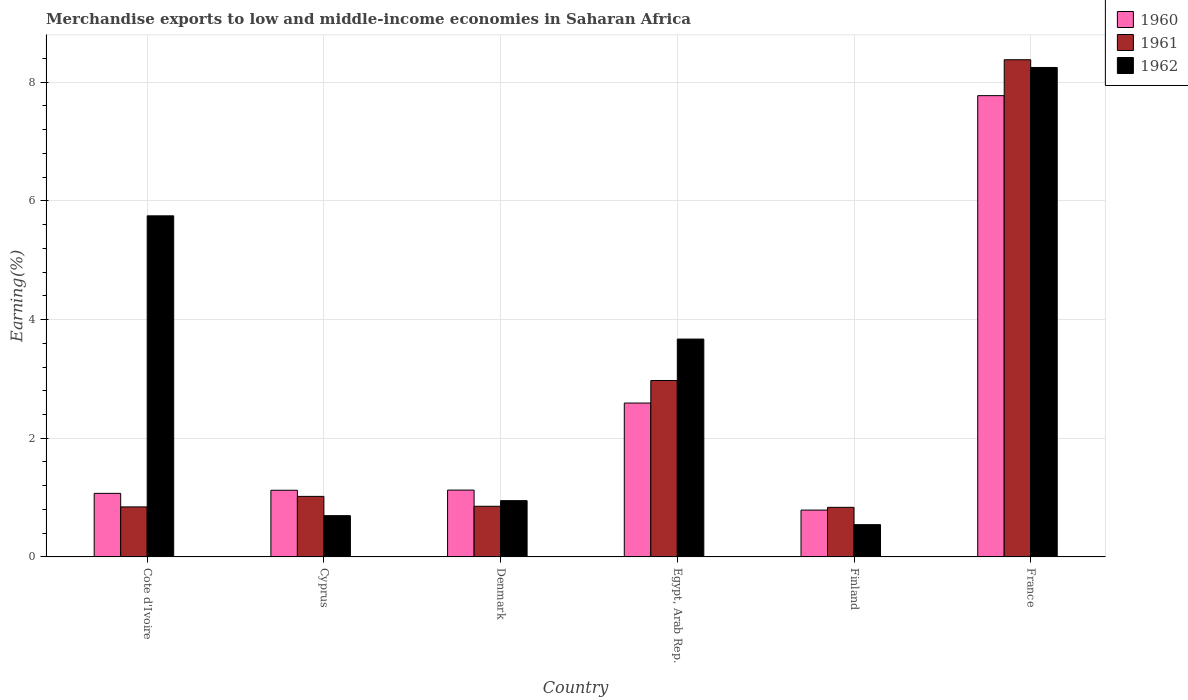How many different coloured bars are there?
Your answer should be compact. 3. Are the number of bars on each tick of the X-axis equal?
Your answer should be compact. Yes. How many bars are there on the 6th tick from the left?
Provide a succinct answer. 3. What is the label of the 1st group of bars from the left?
Ensure brevity in your answer.  Cote d'Ivoire. In how many cases, is the number of bars for a given country not equal to the number of legend labels?
Your answer should be compact. 0. What is the percentage of amount earned from merchandise exports in 1962 in Egypt, Arab Rep.?
Make the answer very short. 3.67. Across all countries, what is the maximum percentage of amount earned from merchandise exports in 1960?
Your response must be concise. 7.77. Across all countries, what is the minimum percentage of amount earned from merchandise exports in 1960?
Ensure brevity in your answer.  0.79. What is the total percentage of amount earned from merchandise exports in 1961 in the graph?
Your answer should be compact. 14.91. What is the difference between the percentage of amount earned from merchandise exports in 1962 in Cote d'Ivoire and that in Cyprus?
Make the answer very short. 5.05. What is the difference between the percentage of amount earned from merchandise exports in 1960 in Finland and the percentage of amount earned from merchandise exports in 1962 in Cote d'Ivoire?
Make the answer very short. -4.96. What is the average percentage of amount earned from merchandise exports in 1960 per country?
Provide a short and direct response. 2.41. What is the difference between the percentage of amount earned from merchandise exports of/in 1962 and percentage of amount earned from merchandise exports of/in 1961 in Finland?
Your answer should be very brief. -0.29. What is the ratio of the percentage of amount earned from merchandise exports in 1960 in Egypt, Arab Rep. to that in Finland?
Your answer should be compact. 3.29. Is the percentage of amount earned from merchandise exports in 1961 in Egypt, Arab Rep. less than that in Finland?
Your answer should be compact. No. What is the difference between the highest and the second highest percentage of amount earned from merchandise exports in 1960?
Give a very brief answer. -1.47. What is the difference between the highest and the lowest percentage of amount earned from merchandise exports in 1961?
Offer a very short reply. 7.54. Is the sum of the percentage of amount earned from merchandise exports in 1962 in Denmark and France greater than the maximum percentage of amount earned from merchandise exports in 1961 across all countries?
Offer a very short reply. Yes. What does the 1st bar from the left in Finland represents?
Provide a succinct answer. 1960. How many bars are there?
Give a very brief answer. 18. What is the difference between two consecutive major ticks on the Y-axis?
Keep it short and to the point. 2. Are the values on the major ticks of Y-axis written in scientific E-notation?
Your response must be concise. No. Does the graph contain any zero values?
Give a very brief answer. No. What is the title of the graph?
Offer a very short reply. Merchandise exports to low and middle-income economies in Saharan Africa. Does "1982" appear as one of the legend labels in the graph?
Your answer should be compact. No. What is the label or title of the Y-axis?
Offer a very short reply. Earning(%). What is the Earning(%) of 1960 in Cote d'Ivoire?
Make the answer very short. 1.07. What is the Earning(%) of 1961 in Cote d'Ivoire?
Provide a short and direct response. 0.84. What is the Earning(%) of 1962 in Cote d'Ivoire?
Your response must be concise. 5.75. What is the Earning(%) of 1960 in Cyprus?
Keep it short and to the point. 1.12. What is the Earning(%) of 1961 in Cyprus?
Provide a short and direct response. 1.02. What is the Earning(%) of 1962 in Cyprus?
Offer a very short reply. 0.7. What is the Earning(%) of 1960 in Denmark?
Provide a succinct answer. 1.13. What is the Earning(%) in 1961 in Denmark?
Keep it short and to the point. 0.85. What is the Earning(%) in 1962 in Denmark?
Give a very brief answer. 0.95. What is the Earning(%) in 1960 in Egypt, Arab Rep.?
Provide a succinct answer. 2.59. What is the Earning(%) of 1961 in Egypt, Arab Rep.?
Ensure brevity in your answer.  2.97. What is the Earning(%) in 1962 in Egypt, Arab Rep.?
Keep it short and to the point. 3.67. What is the Earning(%) in 1960 in Finland?
Offer a very short reply. 0.79. What is the Earning(%) in 1961 in Finland?
Your answer should be compact. 0.84. What is the Earning(%) of 1962 in Finland?
Ensure brevity in your answer.  0.54. What is the Earning(%) in 1960 in France?
Make the answer very short. 7.77. What is the Earning(%) of 1961 in France?
Your answer should be very brief. 8.38. What is the Earning(%) of 1962 in France?
Give a very brief answer. 8.25. Across all countries, what is the maximum Earning(%) in 1960?
Provide a short and direct response. 7.77. Across all countries, what is the maximum Earning(%) in 1961?
Offer a very short reply. 8.38. Across all countries, what is the maximum Earning(%) in 1962?
Your answer should be very brief. 8.25. Across all countries, what is the minimum Earning(%) of 1960?
Make the answer very short. 0.79. Across all countries, what is the minimum Earning(%) in 1961?
Provide a succinct answer. 0.84. Across all countries, what is the minimum Earning(%) of 1962?
Your answer should be compact. 0.54. What is the total Earning(%) of 1960 in the graph?
Offer a very short reply. 14.48. What is the total Earning(%) of 1961 in the graph?
Ensure brevity in your answer.  14.91. What is the total Earning(%) of 1962 in the graph?
Offer a very short reply. 19.86. What is the difference between the Earning(%) in 1960 in Cote d'Ivoire and that in Cyprus?
Make the answer very short. -0.05. What is the difference between the Earning(%) of 1961 in Cote d'Ivoire and that in Cyprus?
Make the answer very short. -0.18. What is the difference between the Earning(%) of 1962 in Cote d'Ivoire and that in Cyprus?
Provide a succinct answer. 5.05. What is the difference between the Earning(%) in 1960 in Cote d'Ivoire and that in Denmark?
Keep it short and to the point. -0.06. What is the difference between the Earning(%) of 1961 in Cote d'Ivoire and that in Denmark?
Offer a terse response. -0.01. What is the difference between the Earning(%) of 1962 in Cote d'Ivoire and that in Denmark?
Give a very brief answer. 4.8. What is the difference between the Earning(%) of 1960 in Cote d'Ivoire and that in Egypt, Arab Rep.?
Make the answer very short. -1.52. What is the difference between the Earning(%) of 1961 in Cote d'Ivoire and that in Egypt, Arab Rep.?
Provide a succinct answer. -2.13. What is the difference between the Earning(%) in 1962 in Cote d'Ivoire and that in Egypt, Arab Rep.?
Provide a succinct answer. 2.08. What is the difference between the Earning(%) of 1960 in Cote d'Ivoire and that in Finland?
Your answer should be compact. 0.28. What is the difference between the Earning(%) in 1961 in Cote d'Ivoire and that in Finland?
Your answer should be compact. 0.01. What is the difference between the Earning(%) in 1962 in Cote d'Ivoire and that in Finland?
Offer a very short reply. 5.2. What is the difference between the Earning(%) in 1960 in Cote d'Ivoire and that in France?
Your answer should be very brief. -6.7. What is the difference between the Earning(%) of 1961 in Cote d'Ivoire and that in France?
Your answer should be compact. -7.54. What is the difference between the Earning(%) in 1962 in Cote d'Ivoire and that in France?
Provide a succinct answer. -2.5. What is the difference between the Earning(%) of 1960 in Cyprus and that in Denmark?
Provide a succinct answer. -0. What is the difference between the Earning(%) of 1961 in Cyprus and that in Denmark?
Your response must be concise. 0.17. What is the difference between the Earning(%) in 1962 in Cyprus and that in Denmark?
Keep it short and to the point. -0.25. What is the difference between the Earning(%) of 1960 in Cyprus and that in Egypt, Arab Rep.?
Offer a terse response. -1.47. What is the difference between the Earning(%) of 1961 in Cyprus and that in Egypt, Arab Rep.?
Ensure brevity in your answer.  -1.95. What is the difference between the Earning(%) of 1962 in Cyprus and that in Egypt, Arab Rep.?
Offer a terse response. -2.98. What is the difference between the Earning(%) of 1960 in Cyprus and that in Finland?
Your answer should be very brief. 0.33. What is the difference between the Earning(%) in 1961 in Cyprus and that in Finland?
Your answer should be very brief. 0.18. What is the difference between the Earning(%) in 1962 in Cyprus and that in Finland?
Your answer should be very brief. 0.15. What is the difference between the Earning(%) in 1960 in Cyprus and that in France?
Offer a very short reply. -6.65. What is the difference between the Earning(%) in 1961 in Cyprus and that in France?
Give a very brief answer. -7.36. What is the difference between the Earning(%) of 1962 in Cyprus and that in France?
Your answer should be compact. -7.55. What is the difference between the Earning(%) in 1960 in Denmark and that in Egypt, Arab Rep.?
Keep it short and to the point. -1.47. What is the difference between the Earning(%) in 1961 in Denmark and that in Egypt, Arab Rep.?
Make the answer very short. -2.12. What is the difference between the Earning(%) in 1962 in Denmark and that in Egypt, Arab Rep.?
Your response must be concise. -2.72. What is the difference between the Earning(%) of 1960 in Denmark and that in Finland?
Offer a very short reply. 0.34. What is the difference between the Earning(%) of 1961 in Denmark and that in Finland?
Make the answer very short. 0.02. What is the difference between the Earning(%) of 1962 in Denmark and that in Finland?
Provide a succinct answer. 0.4. What is the difference between the Earning(%) of 1960 in Denmark and that in France?
Offer a very short reply. -6.65. What is the difference between the Earning(%) of 1961 in Denmark and that in France?
Offer a terse response. -7.53. What is the difference between the Earning(%) in 1962 in Denmark and that in France?
Your answer should be very brief. -7.3. What is the difference between the Earning(%) in 1960 in Egypt, Arab Rep. and that in Finland?
Your response must be concise. 1.8. What is the difference between the Earning(%) in 1961 in Egypt, Arab Rep. and that in Finland?
Make the answer very short. 2.14. What is the difference between the Earning(%) of 1962 in Egypt, Arab Rep. and that in Finland?
Offer a terse response. 3.13. What is the difference between the Earning(%) of 1960 in Egypt, Arab Rep. and that in France?
Make the answer very short. -5.18. What is the difference between the Earning(%) in 1961 in Egypt, Arab Rep. and that in France?
Your answer should be compact. -5.41. What is the difference between the Earning(%) of 1962 in Egypt, Arab Rep. and that in France?
Provide a short and direct response. -4.58. What is the difference between the Earning(%) of 1960 in Finland and that in France?
Offer a terse response. -6.98. What is the difference between the Earning(%) in 1961 in Finland and that in France?
Provide a succinct answer. -7.54. What is the difference between the Earning(%) of 1962 in Finland and that in France?
Keep it short and to the point. -7.7. What is the difference between the Earning(%) of 1960 in Cote d'Ivoire and the Earning(%) of 1961 in Cyprus?
Offer a terse response. 0.05. What is the difference between the Earning(%) in 1960 in Cote d'Ivoire and the Earning(%) in 1962 in Cyprus?
Your answer should be very brief. 0.38. What is the difference between the Earning(%) in 1961 in Cote d'Ivoire and the Earning(%) in 1962 in Cyprus?
Ensure brevity in your answer.  0.15. What is the difference between the Earning(%) of 1960 in Cote d'Ivoire and the Earning(%) of 1961 in Denmark?
Your answer should be compact. 0.22. What is the difference between the Earning(%) of 1960 in Cote d'Ivoire and the Earning(%) of 1962 in Denmark?
Offer a terse response. 0.12. What is the difference between the Earning(%) of 1961 in Cote d'Ivoire and the Earning(%) of 1962 in Denmark?
Offer a very short reply. -0.11. What is the difference between the Earning(%) of 1960 in Cote d'Ivoire and the Earning(%) of 1961 in Egypt, Arab Rep.?
Your answer should be very brief. -1.9. What is the difference between the Earning(%) of 1961 in Cote d'Ivoire and the Earning(%) of 1962 in Egypt, Arab Rep.?
Make the answer very short. -2.83. What is the difference between the Earning(%) of 1960 in Cote d'Ivoire and the Earning(%) of 1961 in Finland?
Your answer should be compact. 0.24. What is the difference between the Earning(%) in 1960 in Cote d'Ivoire and the Earning(%) in 1962 in Finland?
Your answer should be very brief. 0.53. What is the difference between the Earning(%) in 1961 in Cote d'Ivoire and the Earning(%) in 1962 in Finland?
Ensure brevity in your answer.  0.3. What is the difference between the Earning(%) in 1960 in Cote d'Ivoire and the Earning(%) in 1961 in France?
Your response must be concise. -7.31. What is the difference between the Earning(%) in 1960 in Cote d'Ivoire and the Earning(%) in 1962 in France?
Offer a terse response. -7.18. What is the difference between the Earning(%) in 1961 in Cote d'Ivoire and the Earning(%) in 1962 in France?
Your response must be concise. -7.41. What is the difference between the Earning(%) of 1960 in Cyprus and the Earning(%) of 1961 in Denmark?
Make the answer very short. 0.27. What is the difference between the Earning(%) in 1960 in Cyprus and the Earning(%) in 1962 in Denmark?
Give a very brief answer. 0.18. What is the difference between the Earning(%) in 1961 in Cyprus and the Earning(%) in 1962 in Denmark?
Ensure brevity in your answer.  0.07. What is the difference between the Earning(%) of 1960 in Cyprus and the Earning(%) of 1961 in Egypt, Arab Rep.?
Your response must be concise. -1.85. What is the difference between the Earning(%) of 1960 in Cyprus and the Earning(%) of 1962 in Egypt, Arab Rep.?
Provide a short and direct response. -2.55. What is the difference between the Earning(%) of 1961 in Cyprus and the Earning(%) of 1962 in Egypt, Arab Rep.?
Give a very brief answer. -2.65. What is the difference between the Earning(%) in 1960 in Cyprus and the Earning(%) in 1961 in Finland?
Offer a very short reply. 0.29. What is the difference between the Earning(%) of 1960 in Cyprus and the Earning(%) of 1962 in Finland?
Offer a terse response. 0.58. What is the difference between the Earning(%) in 1961 in Cyprus and the Earning(%) in 1962 in Finland?
Make the answer very short. 0.48. What is the difference between the Earning(%) of 1960 in Cyprus and the Earning(%) of 1961 in France?
Give a very brief answer. -7.26. What is the difference between the Earning(%) in 1960 in Cyprus and the Earning(%) in 1962 in France?
Offer a terse response. -7.13. What is the difference between the Earning(%) of 1961 in Cyprus and the Earning(%) of 1962 in France?
Your response must be concise. -7.23. What is the difference between the Earning(%) in 1960 in Denmark and the Earning(%) in 1961 in Egypt, Arab Rep.?
Make the answer very short. -1.85. What is the difference between the Earning(%) of 1960 in Denmark and the Earning(%) of 1962 in Egypt, Arab Rep.?
Offer a terse response. -2.54. What is the difference between the Earning(%) of 1961 in Denmark and the Earning(%) of 1962 in Egypt, Arab Rep.?
Your answer should be compact. -2.82. What is the difference between the Earning(%) in 1960 in Denmark and the Earning(%) in 1961 in Finland?
Keep it short and to the point. 0.29. What is the difference between the Earning(%) of 1960 in Denmark and the Earning(%) of 1962 in Finland?
Offer a very short reply. 0.58. What is the difference between the Earning(%) of 1961 in Denmark and the Earning(%) of 1962 in Finland?
Provide a succinct answer. 0.31. What is the difference between the Earning(%) in 1960 in Denmark and the Earning(%) in 1961 in France?
Give a very brief answer. -7.25. What is the difference between the Earning(%) of 1960 in Denmark and the Earning(%) of 1962 in France?
Provide a short and direct response. -7.12. What is the difference between the Earning(%) of 1961 in Denmark and the Earning(%) of 1962 in France?
Keep it short and to the point. -7.39. What is the difference between the Earning(%) of 1960 in Egypt, Arab Rep. and the Earning(%) of 1961 in Finland?
Your answer should be compact. 1.76. What is the difference between the Earning(%) in 1960 in Egypt, Arab Rep. and the Earning(%) in 1962 in Finland?
Offer a very short reply. 2.05. What is the difference between the Earning(%) in 1961 in Egypt, Arab Rep. and the Earning(%) in 1962 in Finland?
Offer a terse response. 2.43. What is the difference between the Earning(%) in 1960 in Egypt, Arab Rep. and the Earning(%) in 1961 in France?
Provide a succinct answer. -5.79. What is the difference between the Earning(%) in 1960 in Egypt, Arab Rep. and the Earning(%) in 1962 in France?
Make the answer very short. -5.66. What is the difference between the Earning(%) in 1961 in Egypt, Arab Rep. and the Earning(%) in 1962 in France?
Ensure brevity in your answer.  -5.28. What is the difference between the Earning(%) in 1960 in Finland and the Earning(%) in 1961 in France?
Provide a succinct answer. -7.59. What is the difference between the Earning(%) of 1960 in Finland and the Earning(%) of 1962 in France?
Provide a short and direct response. -7.46. What is the difference between the Earning(%) in 1961 in Finland and the Earning(%) in 1962 in France?
Make the answer very short. -7.41. What is the average Earning(%) in 1960 per country?
Provide a succinct answer. 2.41. What is the average Earning(%) in 1961 per country?
Provide a succinct answer. 2.48. What is the average Earning(%) in 1962 per country?
Offer a very short reply. 3.31. What is the difference between the Earning(%) of 1960 and Earning(%) of 1961 in Cote d'Ivoire?
Provide a succinct answer. 0.23. What is the difference between the Earning(%) in 1960 and Earning(%) in 1962 in Cote d'Ivoire?
Your response must be concise. -4.68. What is the difference between the Earning(%) in 1961 and Earning(%) in 1962 in Cote d'Ivoire?
Provide a succinct answer. -4.91. What is the difference between the Earning(%) of 1960 and Earning(%) of 1961 in Cyprus?
Provide a short and direct response. 0.1. What is the difference between the Earning(%) in 1960 and Earning(%) in 1962 in Cyprus?
Give a very brief answer. 0.43. What is the difference between the Earning(%) in 1961 and Earning(%) in 1962 in Cyprus?
Provide a succinct answer. 0.32. What is the difference between the Earning(%) in 1960 and Earning(%) in 1961 in Denmark?
Your response must be concise. 0.27. What is the difference between the Earning(%) of 1960 and Earning(%) of 1962 in Denmark?
Your answer should be very brief. 0.18. What is the difference between the Earning(%) of 1961 and Earning(%) of 1962 in Denmark?
Offer a very short reply. -0.09. What is the difference between the Earning(%) of 1960 and Earning(%) of 1961 in Egypt, Arab Rep.?
Keep it short and to the point. -0.38. What is the difference between the Earning(%) in 1960 and Earning(%) in 1962 in Egypt, Arab Rep.?
Offer a very short reply. -1.08. What is the difference between the Earning(%) in 1961 and Earning(%) in 1962 in Egypt, Arab Rep.?
Provide a short and direct response. -0.7. What is the difference between the Earning(%) of 1960 and Earning(%) of 1961 in Finland?
Provide a succinct answer. -0.05. What is the difference between the Earning(%) of 1960 and Earning(%) of 1962 in Finland?
Provide a short and direct response. 0.25. What is the difference between the Earning(%) of 1961 and Earning(%) of 1962 in Finland?
Ensure brevity in your answer.  0.29. What is the difference between the Earning(%) in 1960 and Earning(%) in 1961 in France?
Your response must be concise. -0.61. What is the difference between the Earning(%) in 1960 and Earning(%) in 1962 in France?
Offer a terse response. -0.47. What is the difference between the Earning(%) in 1961 and Earning(%) in 1962 in France?
Make the answer very short. 0.13. What is the ratio of the Earning(%) in 1960 in Cote d'Ivoire to that in Cyprus?
Keep it short and to the point. 0.95. What is the ratio of the Earning(%) of 1961 in Cote d'Ivoire to that in Cyprus?
Your response must be concise. 0.83. What is the ratio of the Earning(%) in 1962 in Cote d'Ivoire to that in Cyprus?
Provide a succinct answer. 8.26. What is the ratio of the Earning(%) in 1960 in Cote d'Ivoire to that in Denmark?
Make the answer very short. 0.95. What is the ratio of the Earning(%) of 1962 in Cote d'Ivoire to that in Denmark?
Your response must be concise. 6.06. What is the ratio of the Earning(%) of 1960 in Cote d'Ivoire to that in Egypt, Arab Rep.?
Ensure brevity in your answer.  0.41. What is the ratio of the Earning(%) of 1961 in Cote d'Ivoire to that in Egypt, Arab Rep.?
Offer a very short reply. 0.28. What is the ratio of the Earning(%) in 1962 in Cote d'Ivoire to that in Egypt, Arab Rep.?
Your answer should be compact. 1.57. What is the ratio of the Earning(%) of 1960 in Cote d'Ivoire to that in Finland?
Offer a very short reply. 1.36. What is the ratio of the Earning(%) of 1961 in Cote d'Ivoire to that in Finland?
Provide a succinct answer. 1.01. What is the ratio of the Earning(%) of 1962 in Cote d'Ivoire to that in Finland?
Ensure brevity in your answer.  10.57. What is the ratio of the Earning(%) of 1960 in Cote d'Ivoire to that in France?
Your answer should be compact. 0.14. What is the ratio of the Earning(%) of 1961 in Cote d'Ivoire to that in France?
Your answer should be very brief. 0.1. What is the ratio of the Earning(%) of 1962 in Cote d'Ivoire to that in France?
Your answer should be very brief. 0.7. What is the ratio of the Earning(%) of 1961 in Cyprus to that in Denmark?
Make the answer very short. 1.2. What is the ratio of the Earning(%) of 1962 in Cyprus to that in Denmark?
Provide a short and direct response. 0.73. What is the ratio of the Earning(%) of 1960 in Cyprus to that in Egypt, Arab Rep.?
Offer a terse response. 0.43. What is the ratio of the Earning(%) of 1961 in Cyprus to that in Egypt, Arab Rep.?
Offer a terse response. 0.34. What is the ratio of the Earning(%) in 1962 in Cyprus to that in Egypt, Arab Rep.?
Your answer should be very brief. 0.19. What is the ratio of the Earning(%) in 1960 in Cyprus to that in Finland?
Your response must be concise. 1.42. What is the ratio of the Earning(%) in 1961 in Cyprus to that in Finland?
Offer a very short reply. 1.22. What is the ratio of the Earning(%) in 1962 in Cyprus to that in Finland?
Ensure brevity in your answer.  1.28. What is the ratio of the Earning(%) of 1960 in Cyprus to that in France?
Keep it short and to the point. 0.14. What is the ratio of the Earning(%) in 1961 in Cyprus to that in France?
Offer a very short reply. 0.12. What is the ratio of the Earning(%) in 1962 in Cyprus to that in France?
Offer a terse response. 0.08. What is the ratio of the Earning(%) in 1960 in Denmark to that in Egypt, Arab Rep.?
Keep it short and to the point. 0.43. What is the ratio of the Earning(%) in 1961 in Denmark to that in Egypt, Arab Rep.?
Provide a succinct answer. 0.29. What is the ratio of the Earning(%) of 1962 in Denmark to that in Egypt, Arab Rep.?
Provide a short and direct response. 0.26. What is the ratio of the Earning(%) of 1960 in Denmark to that in Finland?
Ensure brevity in your answer.  1.43. What is the ratio of the Earning(%) in 1961 in Denmark to that in Finland?
Your answer should be very brief. 1.02. What is the ratio of the Earning(%) of 1962 in Denmark to that in Finland?
Your answer should be very brief. 1.74. What is the ratio of the Earning(%) in 1960 in Denmark to that in France?
Offer a terse response. 0.14. What is the ratio of the Earning(%) in 1961 in Denmark to that in France?
Your answer should be very brief. 0.1. What is the ratio of the Earning(%) of 1962 in Denmark to that in France?
Provide a succinct answer. 0.12. What is the ratio of the Earning(%) of 1960 in Egypt, Arab Rep. to that in Finland?
Provide a succinct answer. 3.29. What is the ratio of the Earning(%) in 1961 in Egypt, Arab Rep. to that in Finland?
Your answer should be compact. 3.56. What is the ratio of the Earning(%) of 1962 in Egypt, Arab Rep. to that in Finland?
Offer a very short reply. 6.75. What is the ratio of the Earning(%) in 1960 in Egypt, Arab Rep. to that in France?
Your answer should be compact. 0.33. What is the ratio of the Earning(%) in 1961 in Egypt, Arab Rep. to that in France?
Ensure brevity in your answer.  0.35. What is the ratio of the Earning(%) in 1962 in Egypt, Arab Rep. to that in France?
Offer a terse response. 0.45. What is the ratio of the Earning(%) of 1960 in Finland to that in France?
Offer a terse response. 0.1. What is the ratio of the Earning(%) of 1961 in Finland to that in France?
Ensure brevity in your answer.  0.1. What is the ratio of the Earning(%) of 1962 in Finland to that in France?
Make the answer very short. 0.07. What is the difference between the highest and the second highest Earning(%) in 1960?
Offer a terse response. 5.18. What is the difference between the highest and the second highest Earning(%) of 1961?
Your response must be concise. 5.41. What is the difference between the highest and the second highest Earning(%) in 1962?
Your response must be concise. 2.5. What is the difference between the highest and the lowest Earning(%) in 1960?
Your answer should be very brief. 6.98. What is the difference between the highest and the lowest Earning(%) in 1961?
Give a very brief answer. 7.54. What is the difference between the highest and the lowest Earning(%) in 1962?
Your answer should be compact. 7.7. 